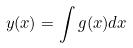<formula> <loc_0><loc_0><loc_500><loc_500>y ( x ) = \int g ( x ) d x</formula> 